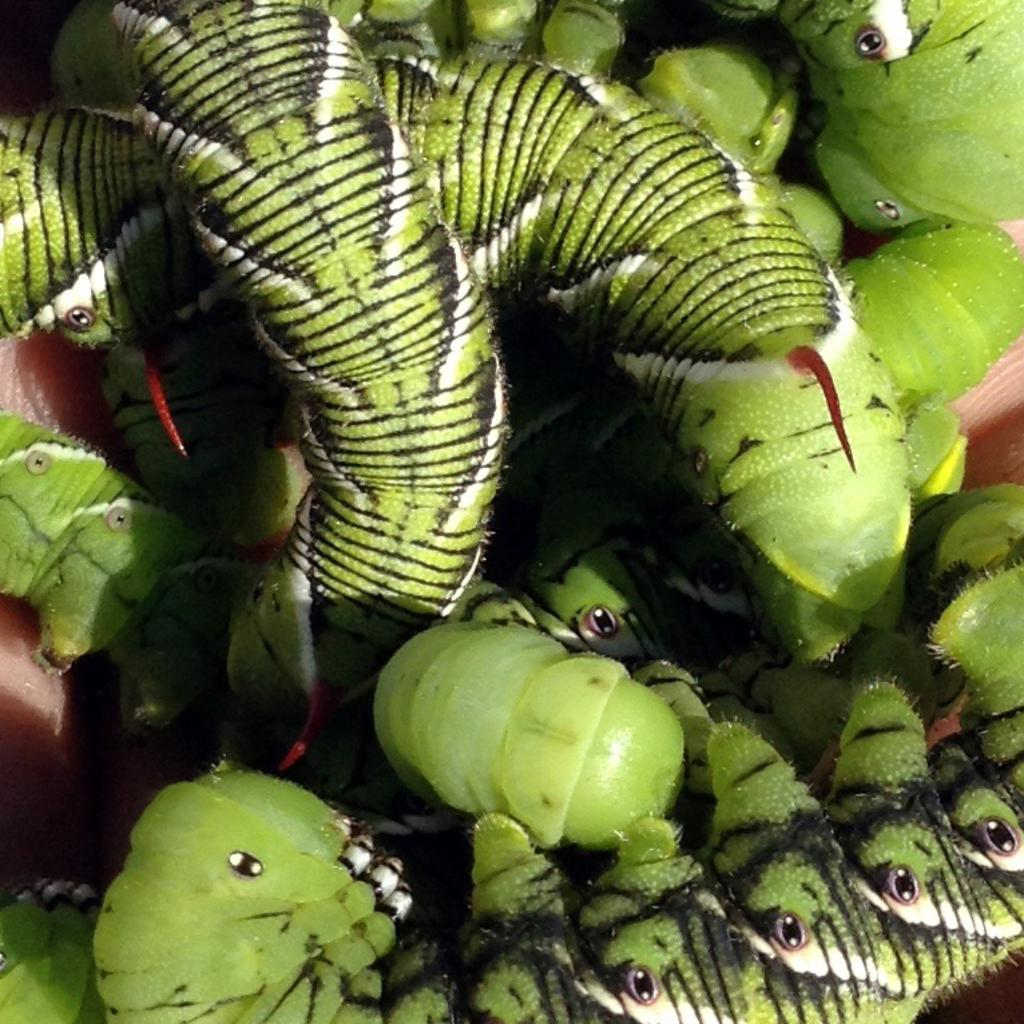What type of animals are present in the image? There are caterpillars in the image. What type of stomach ailment is the caterpillar experiencing in the image? There is no indication of any stomach ailment in the image; it simply shows caterpillars. 